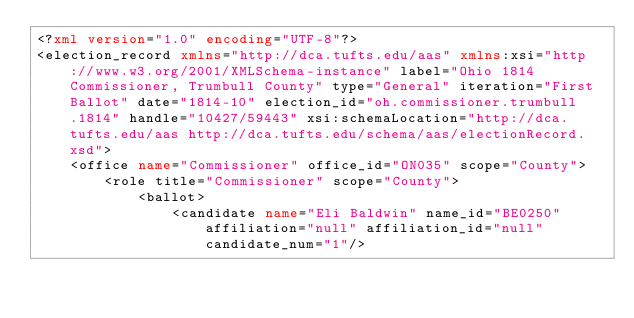<code> <loc_0><loc_0><loc_500><loc_500><_XML_><?xml version="1.0" encoding="UTF-8"?>
<election_record xmlns="http://dca.tufts.edu/aas" xmlns:xsi="http://www.w3.org/2001/XMLSchema-instance" label="Ohio 1814 Commissioner, Trumbull County" type="General" iteration="First Ballot" date="1814-10" election_id="oh.commissioner.trumbull.1814" handle="10427/59443" xsi:schemaLocation="http://dca.tufts.edu/aas http://dca.tufts.edu/schema/aas/electionRecord.xsd">
    <office name="Commissioner" office_id="ON035" scope="County">
        <role title="Commissioner" scope="County">
            <ballot>
                <candidate name="Eli Baldwin" name_id="BE0250" affiliation="null" affiliation_id="null" candidate_num="1"/></code> 